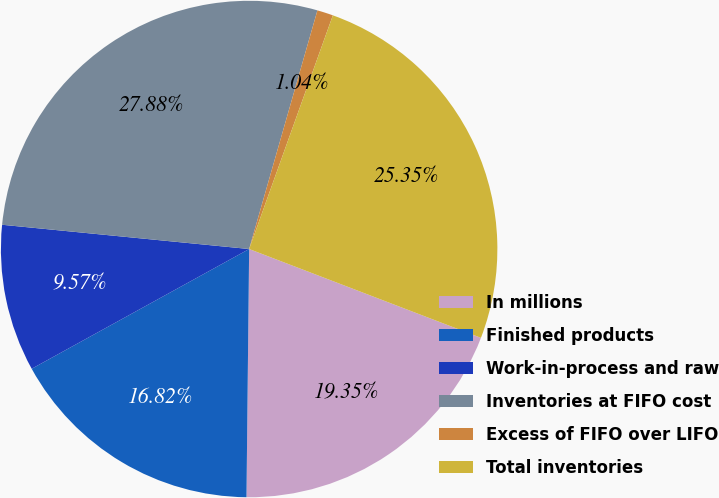Convert chart to OTSL. <chart><loc_0><loc_0><loc_500><loc_500><pie_chart><fcel>In millions<fcel>Finished products<fcel>Work-in-process and raw<fcel>Inventories at FIFO cost<fcel>Excess of FIFO over LIFO<fcel>Total inventories<nl><fcel>19.35%<fcel>16.82%<fcel>9.57%<fcel>27.88%<fcel>1.04%<fcel>25.35%<nl></chart> 